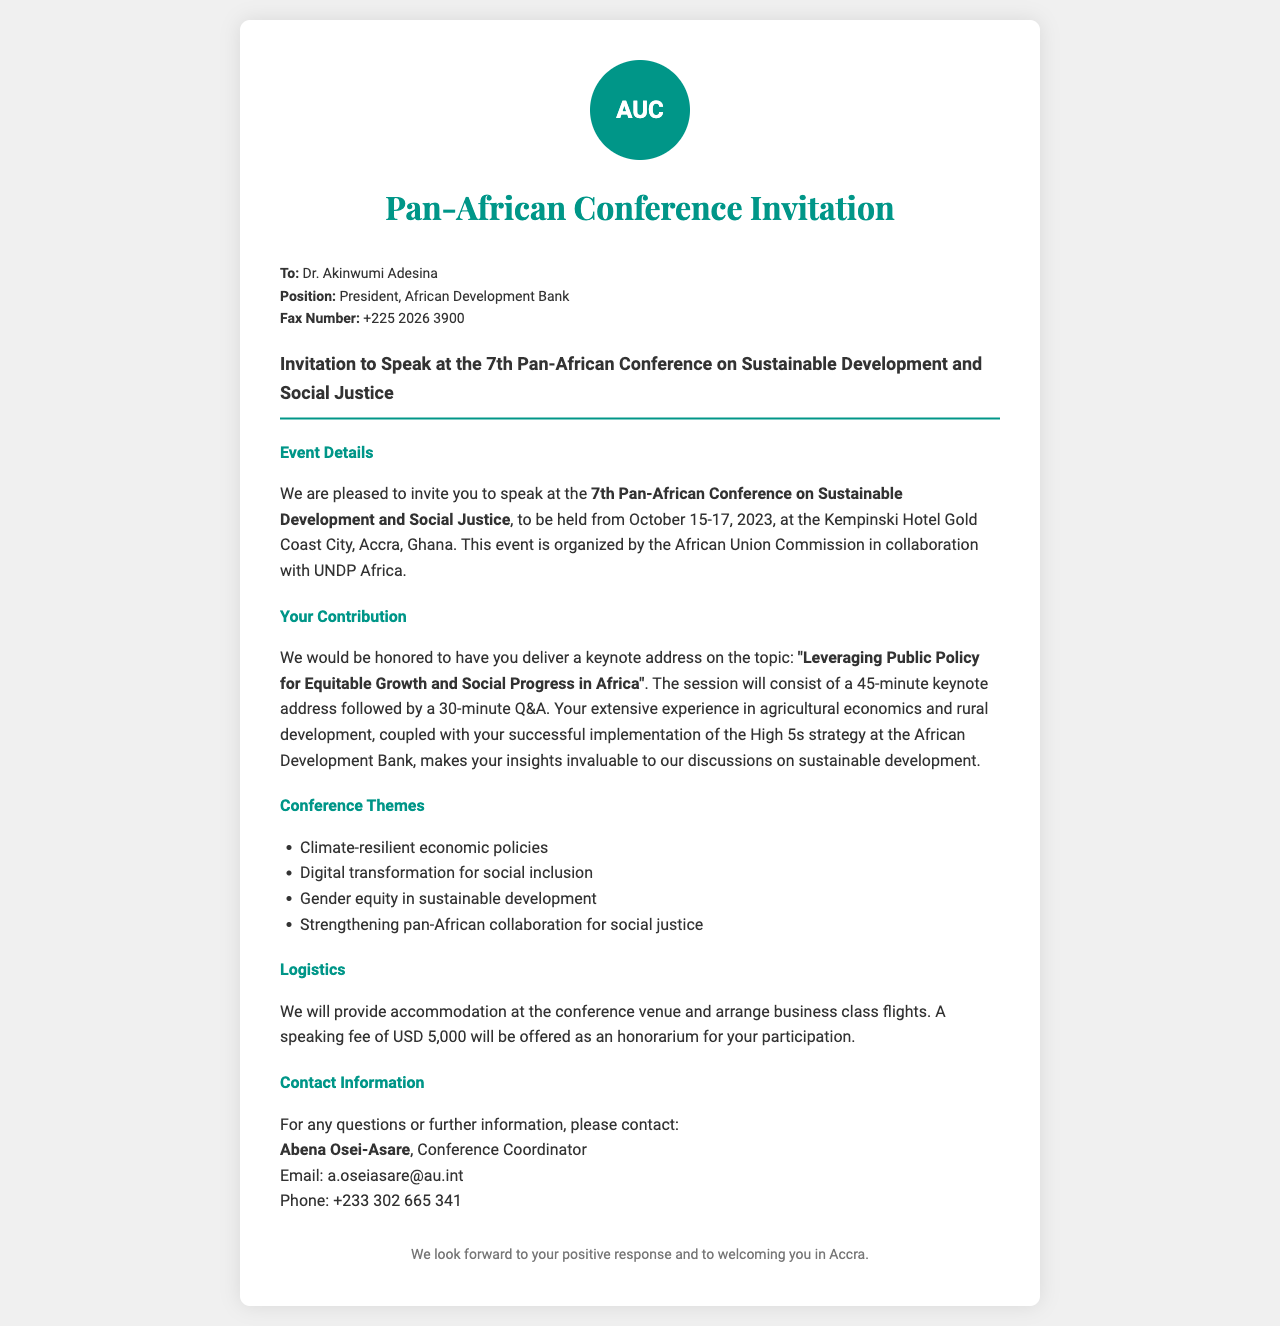What are the dates of the conference? The conference is scheduled from October 15-17, 2023, as stated in the document.
Answer: October 15-17, 2023 Who is the contact person for further information? The document mentions Abena Osei-Asare as the Conference Coordinator for questions or further information.
Answer: Abena Osei-Asare What is the speaking fee offered to Dr. Adesina? The fax states a speaking fee of USD 5,000 as an honorarium for participation.
Answer: USD 5,000 What is the main topic of the keynote address? The document highlights the topic as "Leveraging Public Policy for Equitable Growth and Social Progress in Africa".
Answer: Leveraging Public Policy for Equitable Growth and Social Progress in Africa What hotel will the conference be held at? The fax specifies that the conference will take place at the Kempinski Hotel Gold Coast City in Accra, Ghana.
Answer: Kempinski Hotel Gold Coast City How long will the keynote address be? The document specifies that the keynote address will be 45 minutes long.
Answer: 45 minutes What organization is hosting the conference? The fax states that the African Union Commission is organizing the conference.
Answer: African Union Commission Which theme relates to gender issues? The document lists "Gender equity in sustainable development" as one of the conference themes.
Answer: Gender equity in sustainable development 